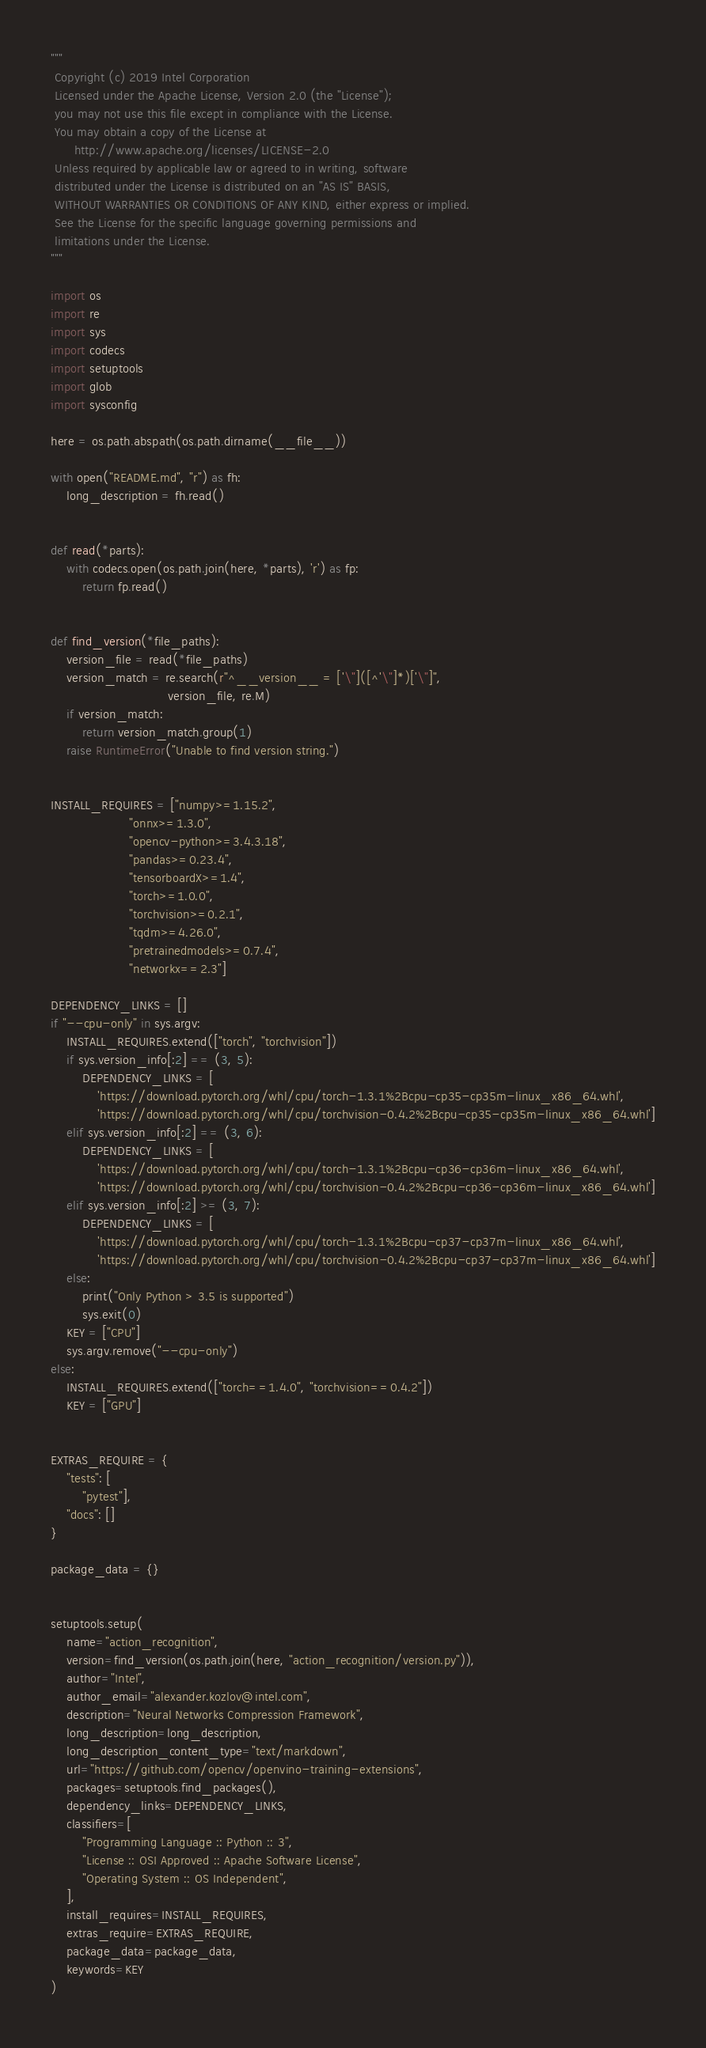<code> <loc_0><loc_0><loc_500><loc_500><_Python_>"""
 Copyright (c) 2019 Intel Corporation
 Licensed under the Apache License, Version 2.0 (the "License");
 you may not use this file except in compliance with the License.
 You may obtain a copy of the License at
      http://www.apache.org/licenses/LICENSE-2.0
 Unless required by applicable law or agreed to in writing, software
 distributed under the License is distributed on an "AS IS" BASIS,
 WITHOUT WARRANTIES OR CONDITIONS OF ANY KIND, either express or implied.
 See the License for the specific language governing permissions and
 limitations under the License.
"""

import os
import re
import sys
import codecs
import setuptools
import glob
import sysconfig

here = os.path.abspath(os.path.dirname(__file__))

with open("README.md", "r") as fh:
    long_description = fh.read()


def read(*parts):
    with codecs.open(os.path.join(here, *parts), 'r') as fp:
        return fp.read()


def find_version(*file_paths):
    version_file = read(*file_paths)
    version_match = re.search(r"^__version__ = ['\"]([^'\"]*)['\"]",
                              version_file, re.M)
    if version_match:
        return version_match.group(1)
    raise RuntimeError("Unable to find version string.")


INSTALL_REQUIRES = ["numpy>=1.15.2",
                    "onnx>=1.3.0",
                    "opencv-python>=3.4.3.18",
                    "pandas>=0.23.4",
                    "tensorboardX>=1.4",
                    "torch>=1.0.0",
                    "torchvision>=0.2.1",
                    "tqdm>=4.26.0",
                    "pretrainedmodels>=0.7.4",
                    "networkx==2.3"]

DEPENDENCY_LINKS = []
if "--cpu-only" in sys.argv:
    INSTALL_REQUIRES.extend(["torch", "torchvision"])
    if sys.version_info[:2] == (3, 5):
        DEPENDENCY_LINKS = [
            'https://download.pytorch.org/whl/cpu/torch-1.3.1%2Bcpu-cp35-cp35m-linux_x86_64.whl',
            'https://download.pytorch.org/whl/cpu/torchvision-0.4.2%2Bcpu-cp35-cp35m-linux_x86_64.whl']
    elif sys.version_info[:2] == (3, 6):
        DEPENDENCY_LINKS = [
            'https://download.pytorch.org/whl/cpu/torch-1.3.1%2Bcpu-cp36-cp36m-linux_x86_64.whl',
            'https://download.pytorch.org/whl/cpu/torchvision-0.4.2%2Bcpu-cp36-cp36m-linux_x86_64.whl']
    elif sys.version_info[:2] >= (3, 7):
        DEPENDENCY_LINKS = [
            'https://download.pytorch.org/whl/cpu/torch-1.3.1%2Bcpu-cp37-cp37m-linux_x86_64.whl',
            'https://download.pytorch.org/whl/cpu/torchvision-0.4.2%2Bcpu-cp37-cp37m-linux_x86_64.whl']
    else:
        print("Only Python > 3.5 is supported")
        sys.exit(0)
    KEY = ["CPU"]
    sys.argv.remove("--cpu-only")
else:
    INSTALL_REQUIRES.extend(["torch==1.4.0", "torchvision==0.4.2"])
    KEY = ["GPU"]


EXTRAS_REQUIRE = {
    "tests": [
        "pytest"],
    "docs": []
}

package_data = {}


setuptools.setup(
    name="action_recognition",
    version=find_version(os.path.join(here, "action_recognition/version.py")),
    author="Intel",
    author_email="alexander.kozlov@intel.com",
    description="Neural Networks Compression Framework",
    long_description=long_description,
    long_description_content_type="text/markdown",
    url="https://github.com/opencv/openvino-training-extensions",
    packages=setuptools.find_packages(),
    dependency_links=DEPENDENCY_LINKS,
    classifiers=[
        "Programming Language :: Python :: 3",
        "License :: OSI Approved :: Apache Software License",
        "Operating System :: OS Independent",
    ],
    install_requires=INSTALL_REQUIRES,
    extras_require=EXTRAS_REQUIRE,
    package_data=package_data,
    keywords=KEY
)

</code> 